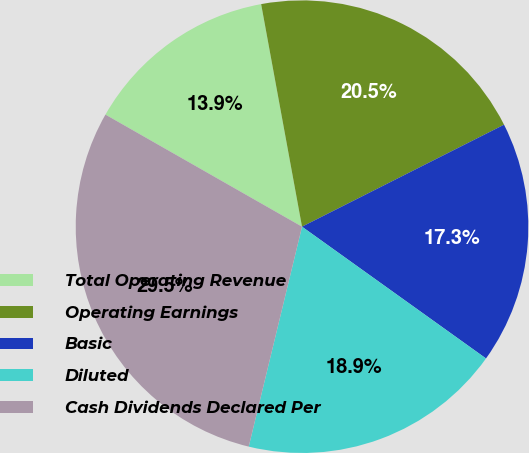Convert chart. <chart><loc_0><loc_0><loc_500><loc_500><pie_chart><fcel>Total Operating Revenue<fcel>Operating Earnings<fcel>Basic<fcel>Diluted<fcel>Cash Dividends Declared Per<nl><fcel>13.86%<fcel>20.45%<fcel>17.33%<fcel>18.89%<fcel>29.46%<nl></chart> 